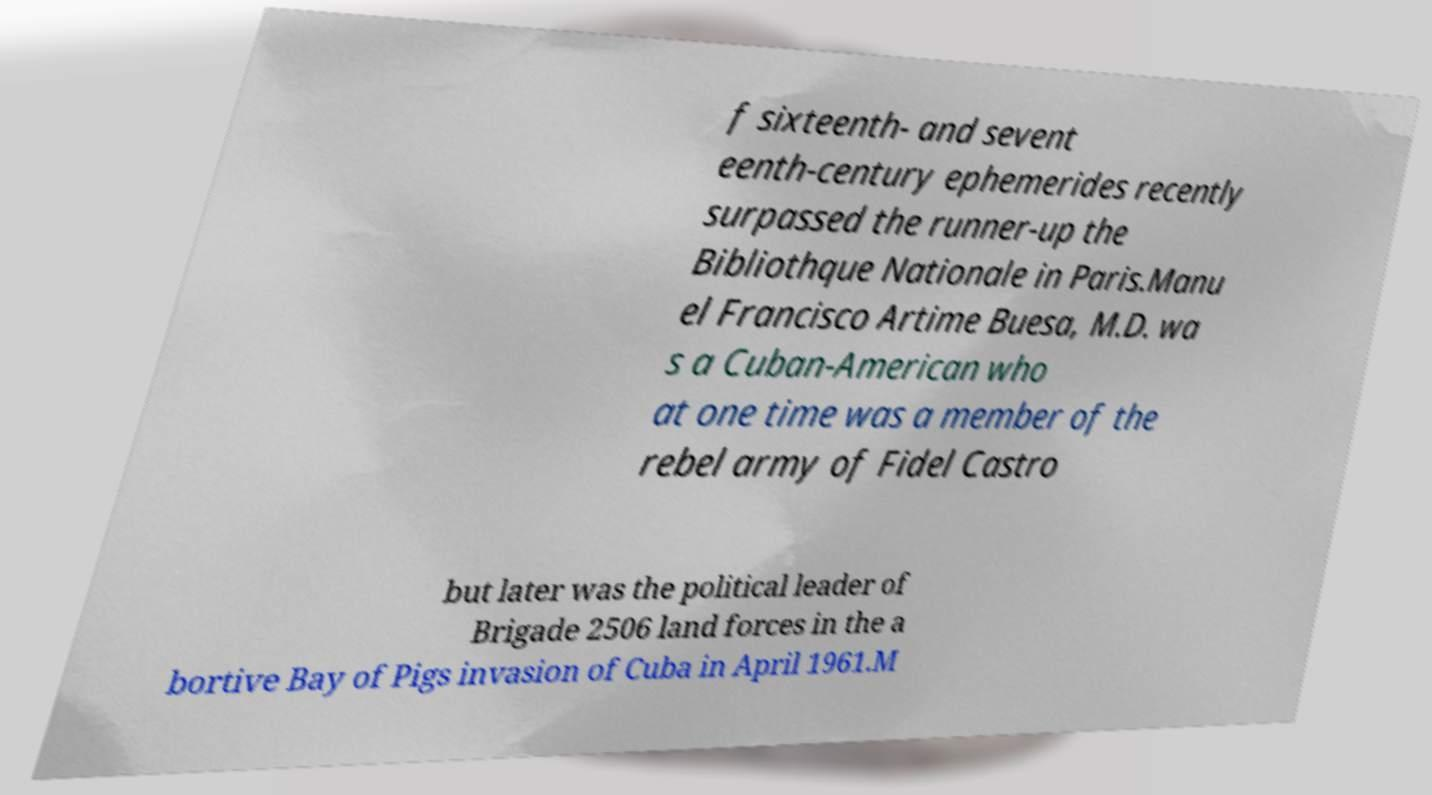There's text embedded in this image that I need extracted. Can you transcribe it verbatim? f sixteenth- and sevent eenth-century ephemerides recently surpassed the runner-up the Bibliothque Nationale in Paris.Manu el Francisco Artime Buesa, M.D. wa s a Cuban-American who at one time was a member of the rebel army of Fidel Castro but later was the political leader of Brigade 2506 land forces in the a bortive Bay of Pigs invasion of Cuba in April 1961.M 